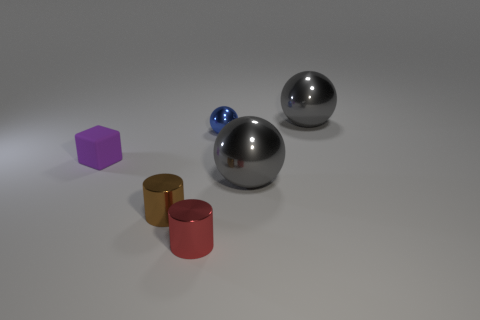Is the color of the big metallic thing behind the small purple rubber block the same as the cube?
Offer a terse response. No. How many large metal things have the same color as the rubber object?
Your answer should be very brief. 0. How many objects are either metallic balls that are behind the purple object or tiny objects that are on the left side of the tiny red thing?
Keep it short and to the point. 4. What is the color of the small ball?
Give a very brief answer. Blue. What number of tiny things are the same material as the small cube?
Give a very brief answer. 0. Is the number of small blue metal objects greater than the number of tiny cyan matte cubes?
Your response must be concise. Yes. How many metal balls are to the right of the big object in front of the purple rubber block?
Provide a succinct answer. 1. How many objects are matte objects to the left of the red shiny cylinder or large yellow balls?
Give a very brief answer. 1. Is there a big gray metallic object that has the same shape as the red object?
Offer a terse response. No. There is a small object that is on the right side of the shiny cylinder that is on the right side of the small brown cylinder; what is its shape?
Provide a short and direct response. Sphere. 